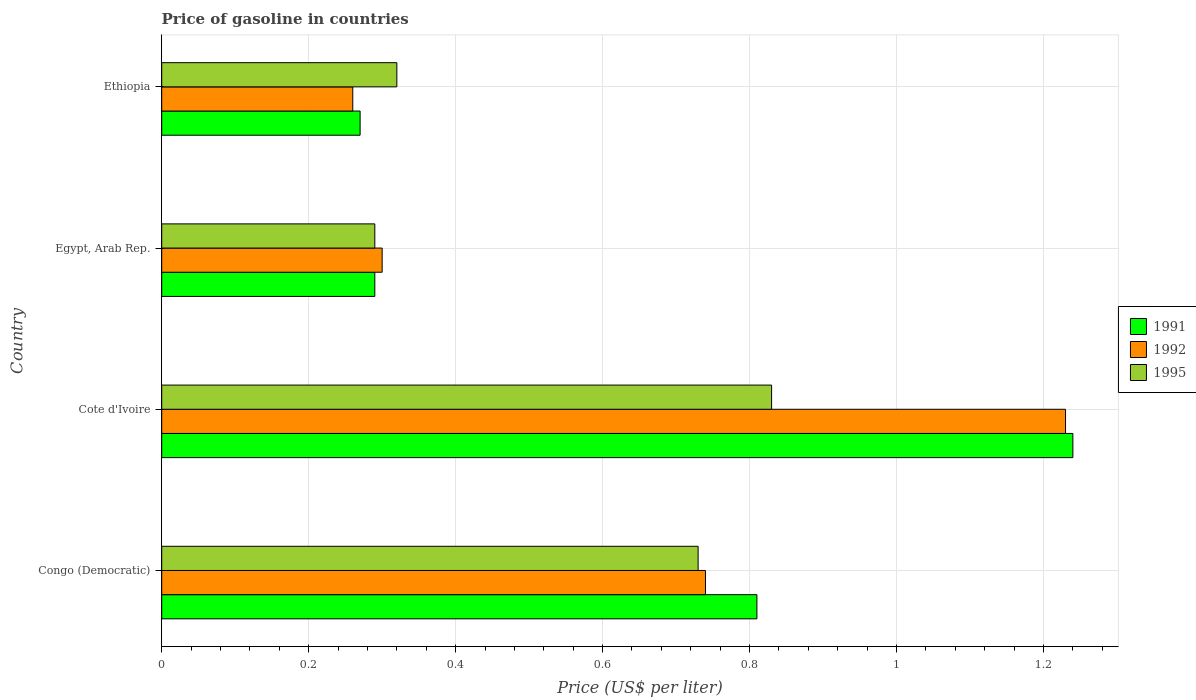What is the label of the 3rd group of bars from the top?
Provide a succinct answer. Cote d'Ivoire. In how many cases, is the number of bars for a given country not equal to the number of legend labels?
Your answer should be compact. 0. What is the price of gasoline in 1995 in Cote d'Ivoire?
Keep it short and to the point. 0.83. Across all countries, what is the maximum price of gasoline in 1991?
Your answer should be very brief. 1.24. Across all countries, what is the minimum price of gasoline in 1992?
Make the answer very short. 0.26. In which country was the price of gasoline in 1991 maximum?
Your answer should be very brief. Cote d'Ivoire. In which country was the price of gasoline in 1995 minimum?
Offer a very short reply. Egypt, Arab Rep. What is the total price of gasoline in 1991 in the graph?
Offer a very short reply. 2.61. What is the difference between the price of gasoline in 1991 in Congo (Democratic) and that in Egypt, Arab Rep.?
Make the answer very short. 0.52. What is the difference between the price of gasoline in 1992 in Congo (Democratic) and the price of gasoline in 1991 in Egypt, Arab Rep.?
Offer a very short reply. 0.45. What is the average price of gasoline in 1995 per country?
Provide a succinct answer. 0.54. What is the difference between the price of gasoline in 1995 and price of gasoline in 1991 in Ethiopia?
Make the answer very short. 0.05. What is the ratio of the price of gasoline in 1992 in Cote d'Ivoire to that in Ethiopia?
Offer a very short reply. 4.73. Is the price of gasoline in 1995 in Congo (Democratic) less than that in Egypt, Arab Rep.?
Offer a terse response. No. What is the difference between the highest and the second highest price of gasoline in 1991?
Your answer should be compact. 0.43. What is the difference between the highest and the lowest price of gasoline in 1992?
Give a very brief answer. 0.97. In how many countries, is the price of gasoline in 1992 greater than the average price of gasoline in 1992 taken over all countries?
Make the answer very short. 2. What does the 2nd bar from the top in Egypt, Arab Rep. represents?
Your answer should be compact. 1992. Is it the case that in every country, the sum of the price of gasoline in 1992 and price of gasoline in 1995 is greater than the price of gasoline in 1991?
Offer a very short reply. Yes. How many bars are there?
Ensure brevity in your answer.  12. Does the graph contain grids?
Your answer should be very brief. Yes. Where does the legend appear in the graph?
Your answer should be compact. Center right. What is the title of the graph?
Provide a succinct answer. Price of gasoline in countries. Does "2012" appear as one of the legend labels in the graph?
Your answer should be compact. No. What is the label or title of the X-axis?
Ensure brevity in your answer.  Price (US$ per liter). What is the label or title of the Y-axis?
Offer a very short reply. Country. What is the Price (US$ per liter) in 1991 in Congo (Democratic)?
Keep it short and to the point. 0.81. What is the Price (US$ per liter) in 1992 in Congo (Democratic)?
Provide a succinct answer. 0.74. What is the Price (US$ per liter) of 1995 in Congo (Democratic)?
Offer a very short reply. 0.73. What is the Price (US$ per liter) in 1991 in Cote d'Ivoire?
Give a very brief answer. 1.24. What is the Price (US$ per liter) in 1992 in Cote d'Ivoire?
Ensure brevity in your answer.  1.23. What is the Price (US$ per liter) in 1995 in Cote d'Ivoire?
Keep it short and to the point. 0.83. What is the Price (US$ per liter) in 1991 in Egypt, Arab Rep.?
Make the answer very short. 0.29. What is the Price (US$ per liter) in 1992 in Egypt, Arab Rep.?
Keep it short and to the point. 0.3. What is the Price (US$ per liter) of 1995 in Egypt, Arab Rep.?
Give a very brief answer. 0.29. What is the Price (US$ per liter) of 1991 in Ethiopia?
Ensure brevity in your answer.  0.27. What is the Price (US$ per liter) of 1992 in Ethiopia?
Your answer should be compact. 0.26. What is the Price (US$ per liter) of 1995 in Ethiopia?
Keep it short and to the point. 0.32. Across all countries, what is the maximum Price (US$ per liter) in 1991?
Provide a short and direct response. 1.24. Across all countries, what is the maximum Price (US$ per liter) in 1992?
Keep it short and to the point. 1.23. Across all countries, what is the maximum Price (US$ per liter) of 1995?
Provide a short and direct response. 0.83. Across all countries, what is the minimum Price (US$ per liter) in 1991?
Make the answer very short. 0.27. Across all countries, what is the minimum Price (US$ per liter) in 1992?
Provide a succinct answer. 0.26. Across all countries, what is the minimum Price (US$ per liter) in 1995?
Provide a succinct answer. 0.29. What is the total Price (US$ per liter) of 1991 in the graph?
Offer a very short reply. 2.61. What is the total Price (US$ per liter) of 1992 in the graph?
Provide a short and direct response. 2.53. What is the total Price (US$ per liter) in 1995 in the graph?
Your answer should be compact. 2.17. What is the difference between the Price (US$ per liter) of 1991 in Congo (Democratic) and that in Cote d'Ivoire?
Make the answer very short. -0.43. What is the difference between the Price (US$ per liter) of 1992 in Congo (Democratic) and that in Cote d'Ivoire?
Offer a very short reply. -0.49. What is the difference between the Price (US$ per liter) of 1995 in Congo (Democratic) and that in Cote d'Ivoire?
Your answer should be very brief. -0.1. What is the difference between the Price (US$ per liter) in 1991 in Congo (Democratic) and that in Egypt, Arab Rep.?
Your answer should be compact. 0.52. What is the difference between the Price (US$ per liter) of 1992 in Congo (Democratic) and that in Egypt, Arab Rep.?
Ensure brevity in your answer.  0.44. What is the difference between the Price (US$ per liter) in 1995 in Congo (Democratic) and that in Egypt, Arab Rep.?
Offer a very short reply. 0.44. What is the difference between the Price (US$ per liter) in 1991 in Congo (Democratic) and that in Ethiopia?
Offer a very short reply. 0.54. What is the difference between the Price (US$ per liter) in 1992 in Congo (Democratic) and that in Ethiopia?
Keep it short and to the point. 0.48. What is the difference between the Price (US$ per liter) in 1995 in Congo (Democratic) and that in Ethiopia?
Your response must be concise. 0.41. What is the difference between the Price (US$ per liter) of 1992 in Cote d'Ivoire and that in Egypt, Arab Rep.?
Your answer should be very brief. 0.93. What is the difference between the Price (US$ per liter) in 1995 in Cote d'Ivoire and that in Egypt, Arab Rep.?
Keep it short and to the point. 0.54. What is the difference between the Price (US$ per liter) in 1991 in Cote d'Ivoire and that in Ethiopia?
Make the answer very short. 0.97. What is the difference between the Price (US$ per liter) of 1992 in Cote d'Ivoire and that in Ethiopia?
Your response must be concise. 0.97. What is the difference between the Price (US$ per liter) of 1995 in Cote d'Ivoire and that in Ethiopia?
Offer a terse response. 0.51. What is the difference between the Price (US$ per liter) in 1992 in Egypt, Arab Rep. and that in Ethiopia?
Make the answer very short. 0.04. What is the difference between the Price (US$ per liter) of 1995 in Egypt, Arab Rep. and that in Ethiopia?
Your answer should be compact. -0.03. What is the difference between the Price (US$ per liter) in 1991 in Congo (Democratic) and the Price (US$ per liter) in 1992 in Cote d'Ivoire?
Offer a terse response. -0.42. What is the difference between the Price (US$ per liter) of 1991 in Congo (Democratic) and the Price (US$ per liter) of 1995 in Cote d'Ivoire?
Your response must be concise. -0.02. What is the difference between the Price (US$ per liter) in 1992 in Congo (Democratic) and the Price (US$ per liter) in 1995 in Cote d'Ivoire?
Keep it short and to the point. -0.09. What is the difference between the Price (US$ per liter) of 1991 in Congo (Democratic) and the Price (US$ per liter) of 1992 in Egypt, Arab Rep.?
Keep it short and to the point. 0.51. What is the difference between the Price (US$ per liter) in 1991 in Congo (Democratic) and the Price (US$ per liter) in 1995 in Egypt, Arab Rep.?
Offer a very short reply. 0.52. What is the difference between the Price (US$ per liter) in 1992 in Congo (Democratic) and the Price (US$ per liter) in 1995 in Egypt, Arab Rep.?
Offer a terse response. 0.45. What is the difference between the Price (US$ per liter) of 1991 in Congo (Democratic) and the Price (US$ per liter) of 1992 in Ethiopia?
Offer a very short reply. 0.55. What is the difference between the Price (US$ per liter) of 1991 in Congo (Democratic) and the Price (US$ per liter) of 1995 in Ethiopia?
Ensure brevity in your answer.  0.49. What is the difference between the Price (US$ per liter) of 1992 in Congo (Democratic) and the Price (US$ per liter) of 1995 in Ethiopia?
Your response must be concise. 0.42. What is the difference between the Price (US$ per liter) of 1991 in Cote d'Ivoire and the Price (US$ per liter) of 1992 in Egypt, Arab Rep.?
Provide a succinct answer. 0.94. What is the difference between the Price (US$ per liter) of 1991 in Cote d'Ivoire and the Price (US$ per liter) of 1995 in Egypt, Arab Rep.?
Give a very brief answer. 0.95. What is the difference between the Price (US$ per liter) of 1992 in Cote d'Ivoire and the Price (US$ per liter) of 1995 in Ethiopia?
Provide a succinct answer. 0.91. What is the difference between the Price (US$ per liter) of 1991 in Egypt, Arab Rep. and the Price (US$ per liter) of 1992 in Ethiopia?
Give a very brief answer. 0.03. What is the difference between the Price (US$ per liter) of 1991 in Egypt, Arab Rep. and the Price (US$ per liter) of 1995 in Ethiopia?
Give a very brief answer. -0.03. What is the difference between the Price (US$ per liter) of 1992 in Egypt, Arab Rep. and the Price (US$ per liter) of 1995 in Ethiopia?
Provide a short and direct response. -0.02. What is the average Price (US$ per liter) in 1991 per country?
Provide a succinct answer. 0.65. What is the average Price (US$ per liter) in 1992 per country?
Make the answer very short. 0.63. What is the average Price (US$ per liter) in 1995 per country?
Your response must be concise. 0.54. What is the difference between the Price (US$ per liter) of 1991 and Price (US$ per liter) of 1992 in Congo (Democratic)?
Your answer should be very brief. 0.07. What is the difference between the Price (US$ per liter) in 1992 and Price (US$ per liter) in 1995 in Congo (Democratic)?
Make the answer very short. 0.01. What is the difference between the Price (US$ per liter) in 1991 and Price (US$ per liter) in 1992 in Cote d'Ivoire?
Provide a short and direct response. 0.01. What is the difference between the Price (US$ per liter) of 1991 and Price (US$ per liter) of 1995 in Cote d'Ivoire?
Your answer should be compact. 0.41. What is the difference between the Price (US$ per liter) of 1992 and Price (US$ per liter) of 1995 in Cote d'Ivoire?
Offer a terse response. 0.4. What is the difference between the Price (US$ per liter) of 1991 and Price (US$ per liter) of 1992 in Egypt, Arab Rep.?
Provide a short and direct response. -0.01. What is the difference between the Price (US$ per liter) of 1992 and Price (US$ per liter) of 1995 in Egypt, Arab Rep.?
Give a very brief answer. 0.01. What is the difference between the Price (US$ per liter) in 1992 and Price (US$ per liter) in 1995 in Ethiopia?
Offer a very short reply. -0.06. What is the ratio of the Price (US$ per liter) in 1991 in Congo (Democratic) to that in Cote d'Ivoire?
Provide a succinct answer. 0.65. What is the ratio of the Price (US$ per liter) of 1992 in Congo (Democratic) to that in Cote d'Ivoire?
Provide a short and direct response. 0.6. What is the ratio of the Price (US$ per liter) of 1995 in Congo (Democratic) to that in Cote d'Ivoire?
Your response must be concise. 0.88. What is the ratio of the Price (US$ per liter) of 1991 in Congo (Democratic) to that in Egypt, Arab Rep.?
Offer a terse response. 2.79. What is the ratio of the Price (US$ per liter) of 1992 in Congo (Democratic) to that in Egypt, Arab Rep.?
Ensure brevity in your answer.  2.47. What is the ratio of the Price (US$ per liter) in 1995 in Congo (Democratic) to that in Egypt, Arab Rep.?
Provide a succinct answer. 2.52. What is the ratio of the Price (US$ per liter) of 1991 in Congo (Democratic) to that in Ethiopia?
Provide a short and direct response. 3. What is the ratio of the Price (US$ per liter) of 1992 in Congo (Democratic) to that in Ethiopia?
Make the answer very short. 2.85. What is the ratio of the Price (US$ per liter) of 1995 in Congo (Democratic) to that in Ethiopia?
Offer a very short reply. 2.28. What is the ratio of the Price (US$ per liter) of 1991 in Cote d'Ivoire to that in Egypt, Arab Rep.?
Your answer should be very brief. 4.28. What is the ratio of the Price (US$ per liter) in 1995 in Cote d'Ivoire to that in Egypt, Arab Rep.?
Offer a very short reply. 2.86. What is the ratio of the Price (US$ per liter) in 1991 in Cote d'Ivoire to that in Ethiopia?
Your response must be concise. 4.59. What is the ratio of the Price (US$ per liter) of 1992 in Cote d'Ivoire to that in Ethiopia?
Your response must be concise. 4.73. What is the ratio of the Price (US$ per liter) in 1995 in Cote d'Ivoire to that in Ethiopia?
Your answer should be very brief. 2.59. What is the ratio of the Price (US$ per liter) in 1991 in Egypt, Arab Rep. to that in Ethiopia?
Keep it short and to the point. 1.07. What is the ratio of the Price (US$ per liter) of 1992 in Egypt, Arab Rep. to that in Ethiopia?
Your answer should be compact. 1.15. What is the ratio of the Price (US$ per liter) of 1995 in Egypt, Arab Rep. to that in Ethiopia?
Keep it short and to the point. 0.91. What is the difference between the highest and the second highest Price (US$ per liter) of 1991?
Keep it short and to the point. 0.43. What is the difference between the highest and the second highest Price (US$ per liter) of 1992?
Your answer should be compact. 0.49. What is the difference between the highest and the second highest Price (US$ per liter) in 1995?
Offer a very short reply. 0.1. What is the difference between the highest and the lowest Price (US$ per liter) of 1992?
Your answer should be very brief. 0.97. What is the difference between the highest and the lowest Price (US$ per liter) of 1995?
Offer a terse response. 0.54. 